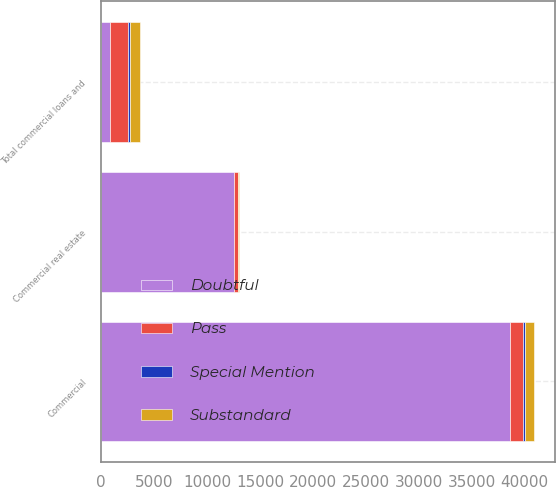Convert chart. <chart><loc_0><loc_0><loc_500><loc_500><stacked_bar_chart><ecel><fcel>Commercial<fcel>Commercial real estate<fcel>Total commercial loans and<nl><fcel>Doubtful<fcel>38600<fcel>12523<fcel>828<nl><fcel>Pass<fcel>1231<fcel>412<fcel>1682<nl><fcel>Substandard<fcel>828<fcel>82<fcel>951<nl><fcel>Special Mention<fcel>198<fcel>6<fcel>204<nl></chart> 